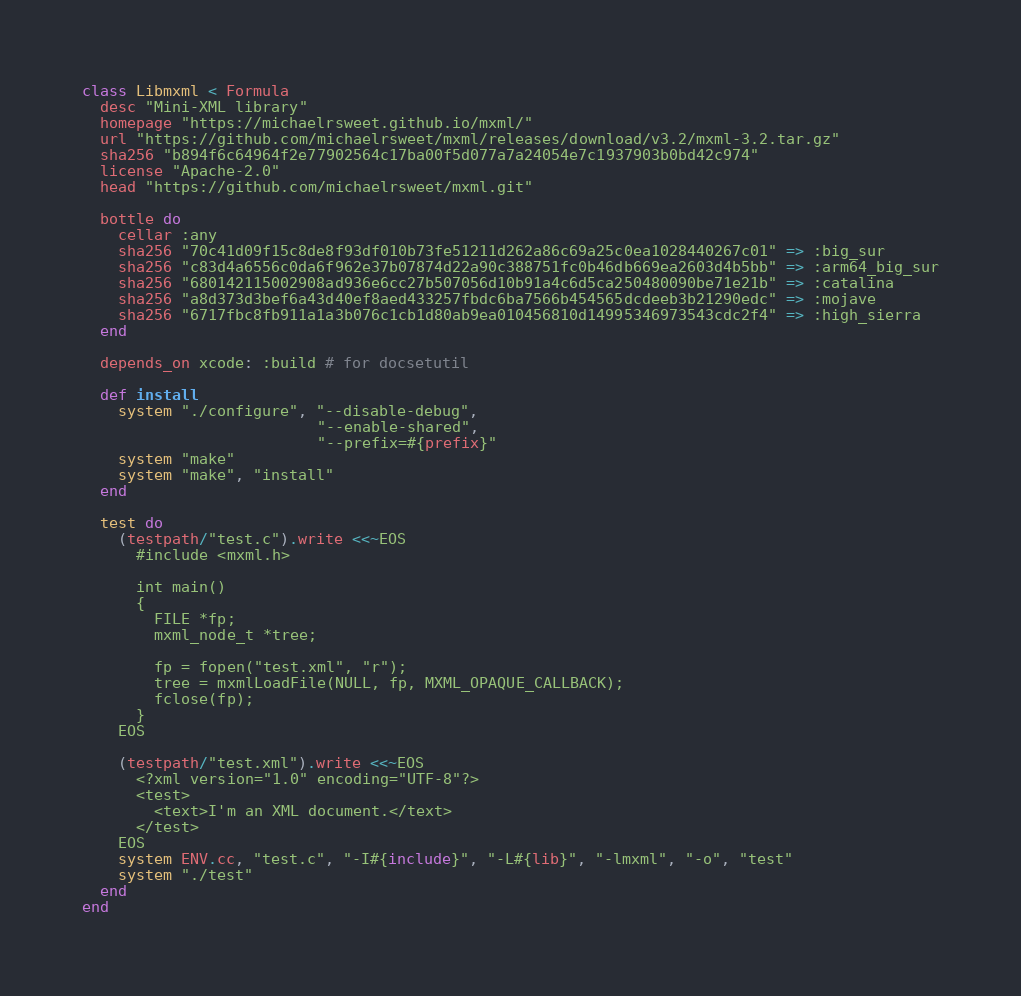<code> <loc_0><loc_0><loc_500><loc_500><_Ruby_>class Libmxml < Formula
  desc "Mini-XML library"
  homepage "https://michaelrsweet.github.io/mxml/"
  url "https://github.com/michaelrsweet/mxml/releases/download/v3.2/mxml-3.2.tar.gz"
  sha256 "b894f6c64964f2e77902564c17ba00f5d077a7a24054e7c1937903b0bd42c974"
  license "Apache-2.0"
  head "https://github.com/michaelrsweet/mxml.git"

  bottle do
    cellar :any
    sha256 "70c41d09f15c8de8f93df010b73fe51211d262a86c69a25c0ea1028440267c01" => :big_sur
    sha256 "c83d4a6556c0da6f962e37b07874d22a90c388751fc0b46db669ea2603d4b5bb" => :arm64_big_sur
    sha256 "680142115002908ad936e6cc27b507056d10b91a4c6d5ca250480090be71e21b" => :catalina
    sha256 "a8d373d3bef6a43d40ef8aed433257fbdc6ba7566b454565dcdeeb3b21290edc" => :mojave
    sha256 "6717fbc8fb911a1a3b076c1cb1d80ab9ea010456810d14995346973543cdc2f4" => :high_sierra
  end

  depends_on xcode: :build # for docsetutil

  def install
    system "./configure", "--disable-debug",
                          "--enable-shared",
                          "--prefix=#{prefix}"
    system "make"
    system "make", "install"
  end

  test do
    (testpath/"test.c").write <<~EOS
      #include <mxml.h>

      int main()
      {
        FILE *fp;
        mxml_node_t *tree;

        fp = fopen("test.xml", "r");
        tree = mxmlLoadFile(NULL, fp, MXML_OPAQUE_CALLBACK);
        fclose(fp);
      }
    EOS

    (testpath/"test.xml").write <<~EOS
      <?xml version="1.0" encoding="UTF-8"?>
      <test>
        <text>I'm an XML document.</text>
      </test>
    EOS
    system ENV.cc, "test.c", "-I#{include}", "-L#{lib}", "-lmxml", "-o", "test"
    system "./test"
  end
end
</code> 